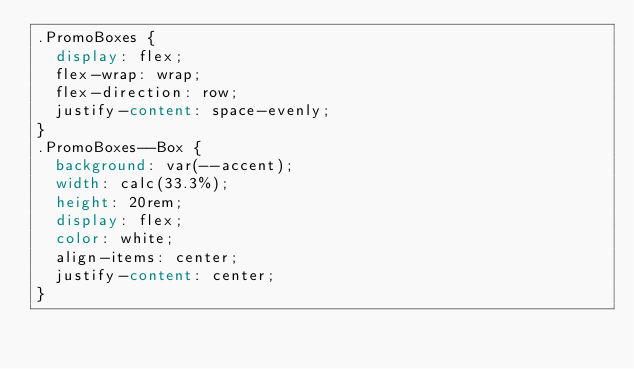<code> <loc_0><loc_0><loc_500><loc_500><_CSS_>.PromoBoxes {
  display: flex;
  flex-wrap: wrap;
  flex-direction: row;
  justify-content: space-evenly;
}
.PromoBoxes--Box {
  background: var(--accent);
  width: calc(33.3%);
  height: 20rem;
  display: flex;
  color: white;
  align-items: center;
  justify-content: center;
}
</code> 